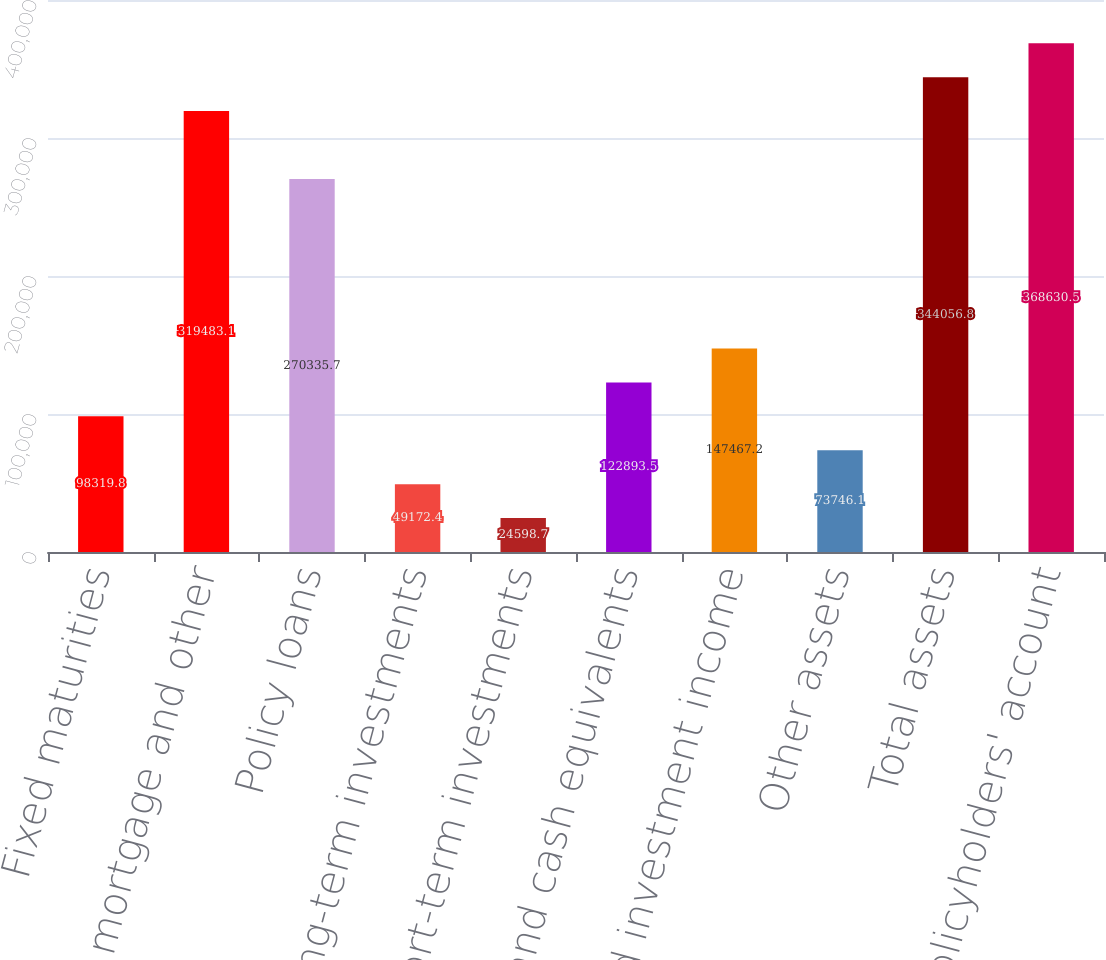Convert chart to OTSL. <chart><loc_0><loc_0><loc_500><loc_500><bar_chart><fcel>Fixed maturities<fcel>Commercial mortgage and other<fcel>Policy loans<fcel>Other long-term investments<fcel>Short-term investments<fcel>Cash and cash equivalents<fcel>Accrued investment income<fcel>Other assets<fcel>Total assets<fcel>Policyholders' account<nl><fcel>98319.8<fcel>319483<fcel>270336<fcel>49172.4<fcel>24598.7<fcel>122894<fcel>147467<fcel>73746.1<fcel>344057<fcel>368630<nl></chart> 